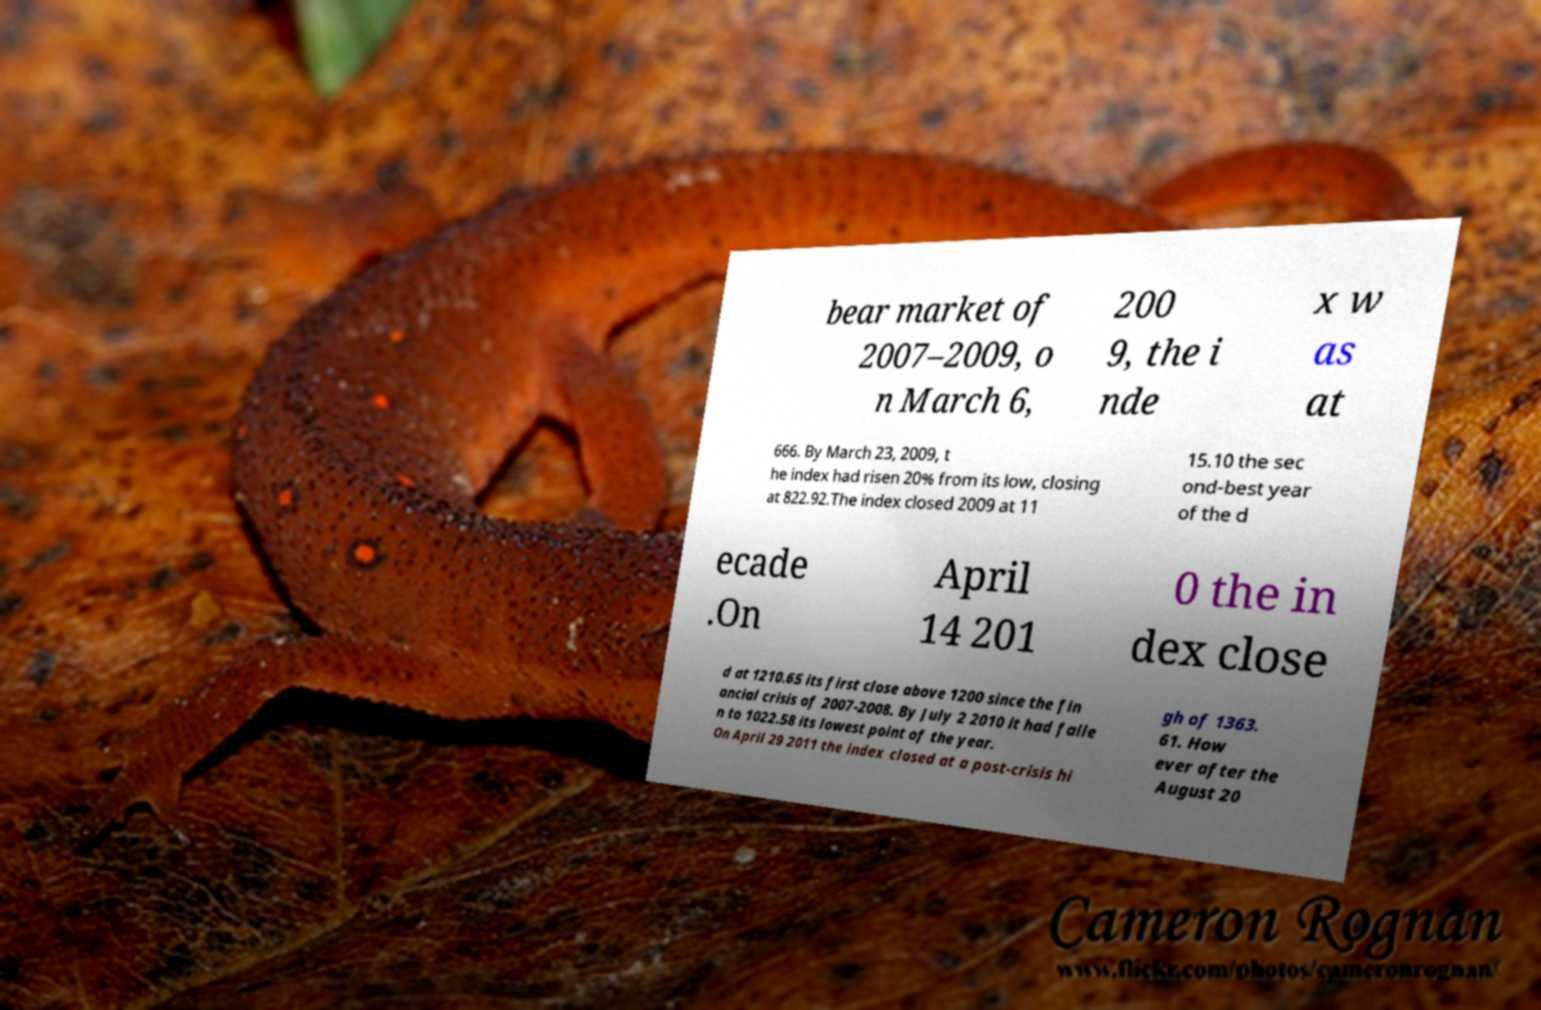Please identify and transcribe the text found in this image. bear market of 2007–2009, o n March 6, 200 9, the i nde x w as at 666. By March 23, 2009, t he index had risen 20% from its low, closing at 822.92.The index closed 2009 at 11 15.10 the sec ond-best year of the d ecade .On April 14 201 0 the in dex close d at 1210.65 its first close above 1200 since the fin ancial crisis of 2007-2008. By July 2 2010 it had falle n to 1022.58 its lowest point of the year. On April 29 2011 the index closed at a post-crisis hi gh of 1363. 61. How ever after the August 20 